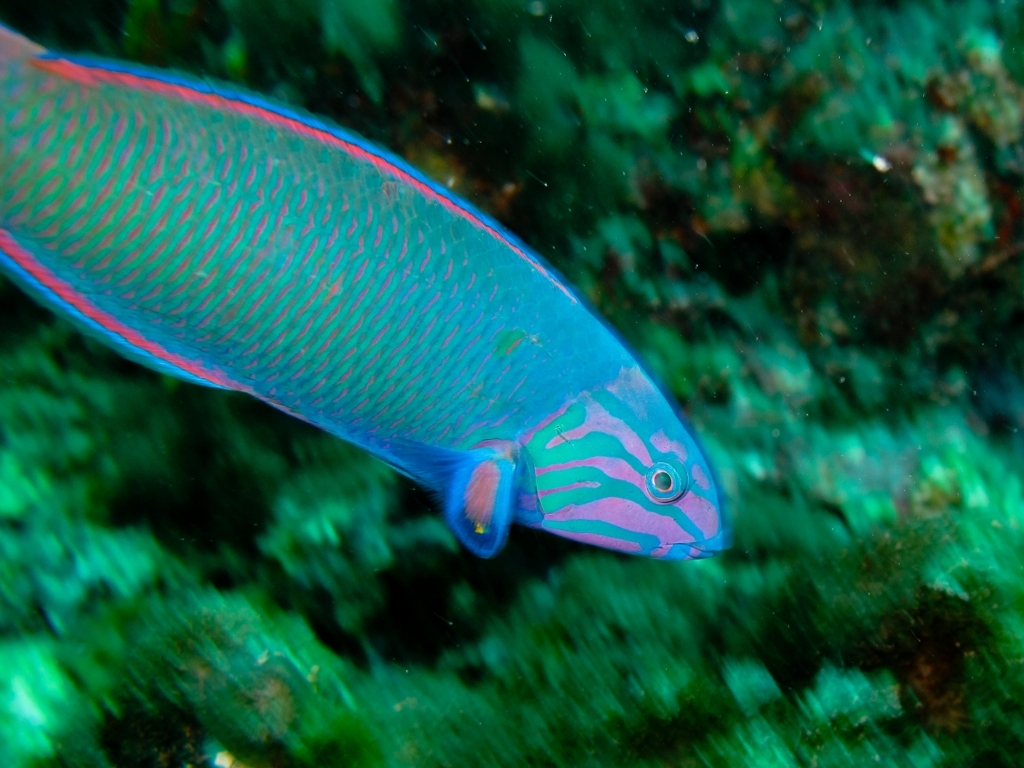Is there no issue with image clarity? The image is relatively clear with fine detail visible on the fish, including scales and patterns, though some minor blurring is present possibly due to the motion of the fish or water. 